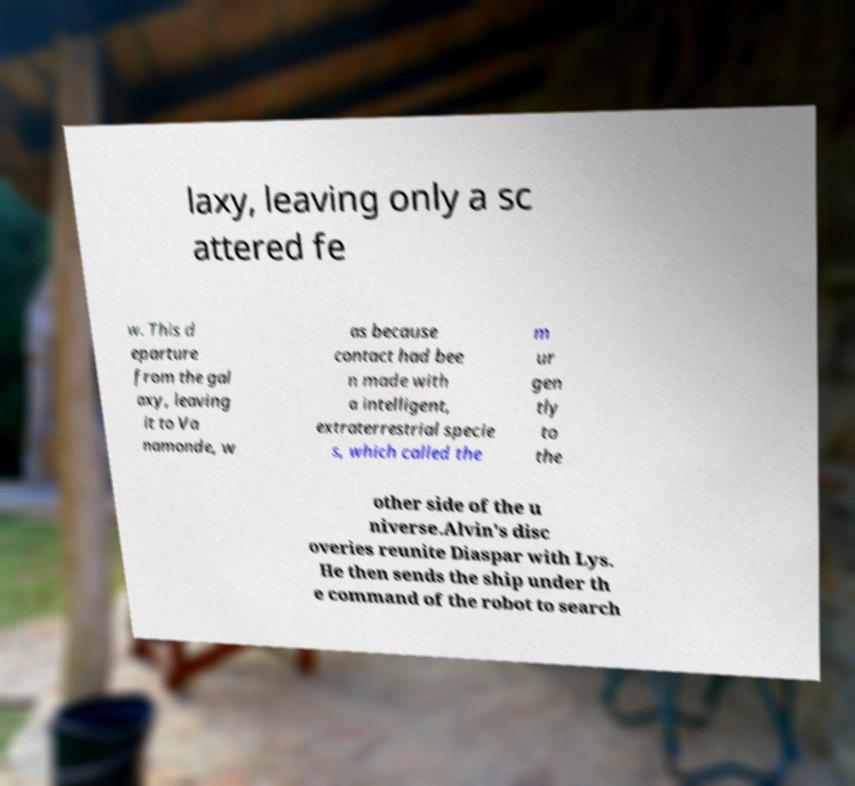Can you accurately transcribe the text from the provided image for me? laxy, leaving only a sc attered fe w. This d eparture from the gal axy, leaving it to Va namonde, w as because contact had bee n made with a intelligent, extraterrestrial specie s, which called the m ur gen tly to the other side of the u niverse.Alvin's disc overies reunite Diaspar with Lys. He then sends the ship under th e command of the robot to search 